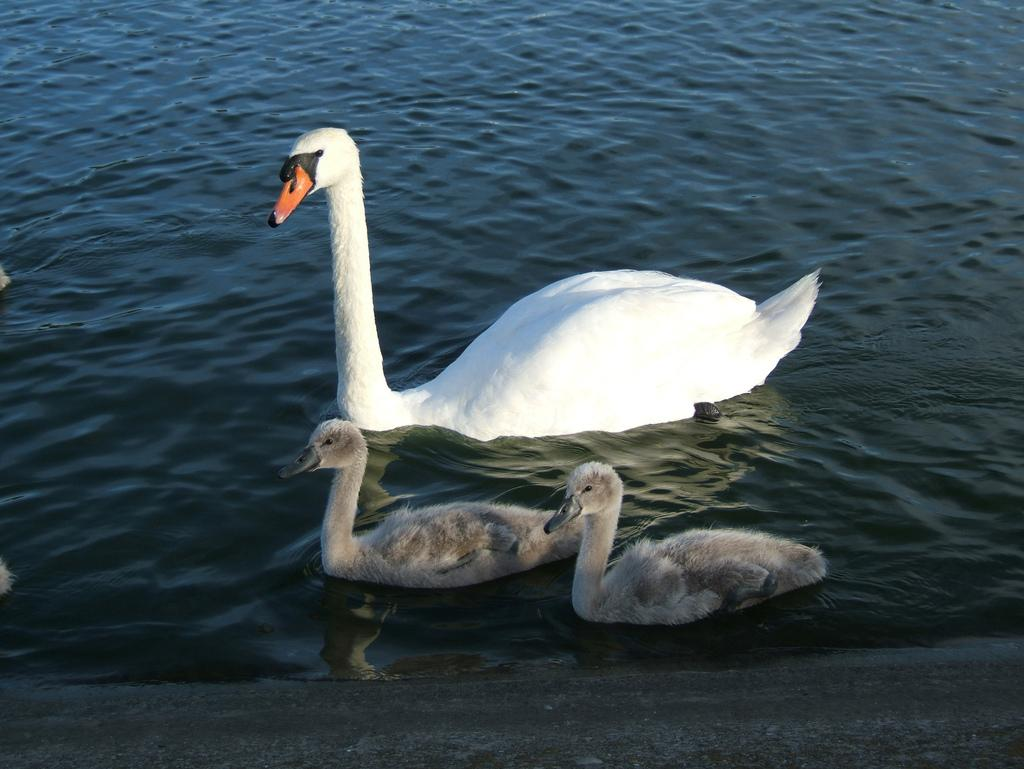What type of animals are in the image? There are swans in the image. Where are the swans located? The swans are in the water. How many cattle are present in the image? There are no cattle present in the image; it features swans in the water. What type of equipment is used by the women in the image? There are no women or equipment present in the image; it only features swans in the water. 